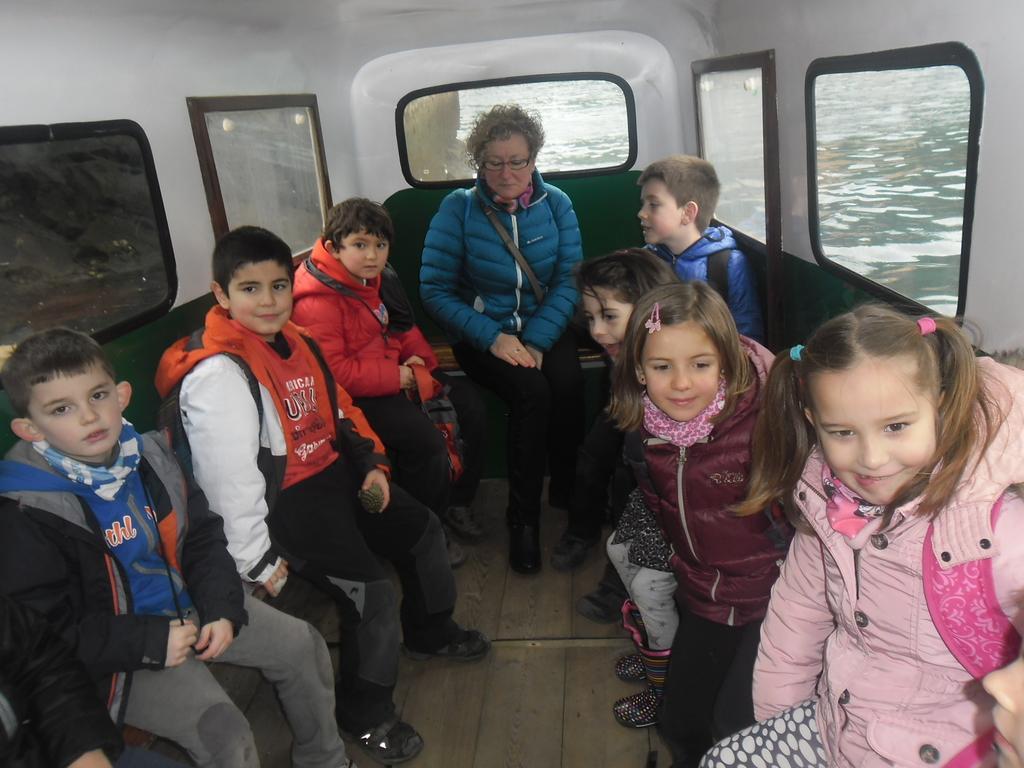How would you summarize this image in a sentence or two? In this image I can see a woman and a group of kids sitting in a boat. The boat is on the surface of water. 